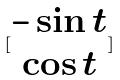Convert formula to latex. <formula><loc_0><loc_0><loc_500><loc_500>[ \begin{matrix} - \sin t \\ \cos t \end{matrix} ]</formula> 